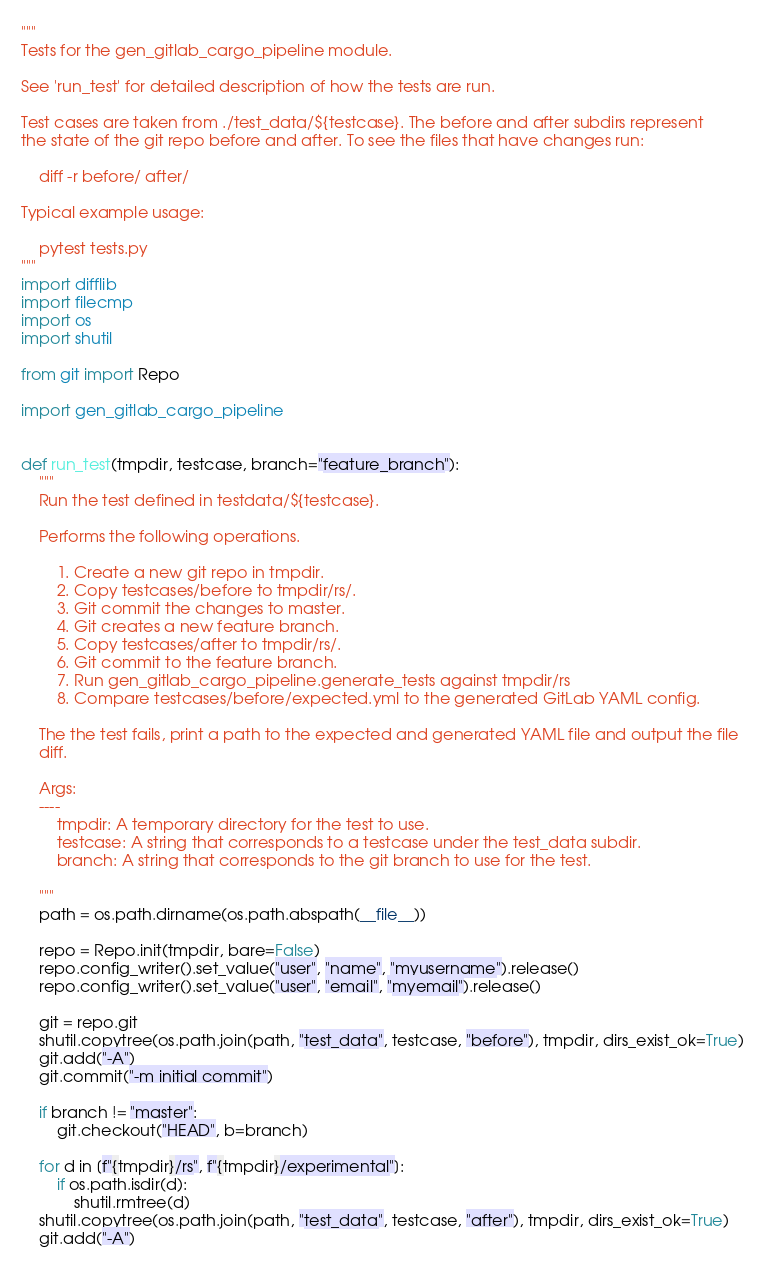Convert code to text. <code><loc_0><loc_0><loc_500><loc_500><_Python_>"""
Tests for the gen_gitlab_cargo_pipeline module.

See 'run_test' for detailed description of how the tests are run.

Test cases are taken from ./test_data/${testcase}. The before and after subdirs represent
the state of the git repo before and after. To see the files that have changes run:

    diff -r before/ after/

Typical example usage:

    pytest tests.py
"""
import difflib
import filecmp
import os
import shutil

from git import Repo

import gen_gitlab_cargo_pipeline


def run_test(tmpdir, testcase, branch="feature_branch"):
    """
    Run the test defined in testdata/${testcase}.

    Performs the following operations.

        1. Create a new git repo in tmpdir.
        2. Copy testcases/before to tmpdir/rs/.
        3. Git commit the changes to master.
        4. Git creates a new feature branch.
        5. Copy testcases/after to tmpdir/rs/.
        6. Git commit to the feature branch.
        7. Run gen_gitlab_cargo_pipeline.generate_tests against tmpdir/rs
        8. Compare testcases/before/expected.yml to the generated GitLab YAML config.

    The the test fails, print a path to the expected and generated YAML file and output the file
    diff.

    Args:
    ----
        tmpdir: A temporary directory for the test to use.
        testcase: A string that corresponds to a testcase under the test_data subdir.
        branch: A string that corresponds to the git branch to use for the test.

    """
    path = os.path.dirname(os.path.abspath(__file__))

    repo = Repo.init(tmpdir, bare=False)
    repo.config_writer().set_value("user", "name", "myusername").release()
    repo.config_writer().set_value("user", "email", "myemail").release()

    git = repo.git
    shutil.copytree(os.path.join(path, "test_data", testcase, "before"), tmpdir, dirs_exist_ok=True)
    git.add("-A")
    git.commit("-m initial commit")

    if branch != "master":
        git.checkout("HEAD", b=branch)

    for d in [f"{tmpdir}/rs", f"{tmpdir}/experimental"]:
        if os.path.isdir(d):
            shutil.rmtree(d)
    shutil.copytree(os.path.join(path, "test_data", testcase, "after"), tmpdir, dirs_exist_ok=True)
    git.add("-A")</code> 